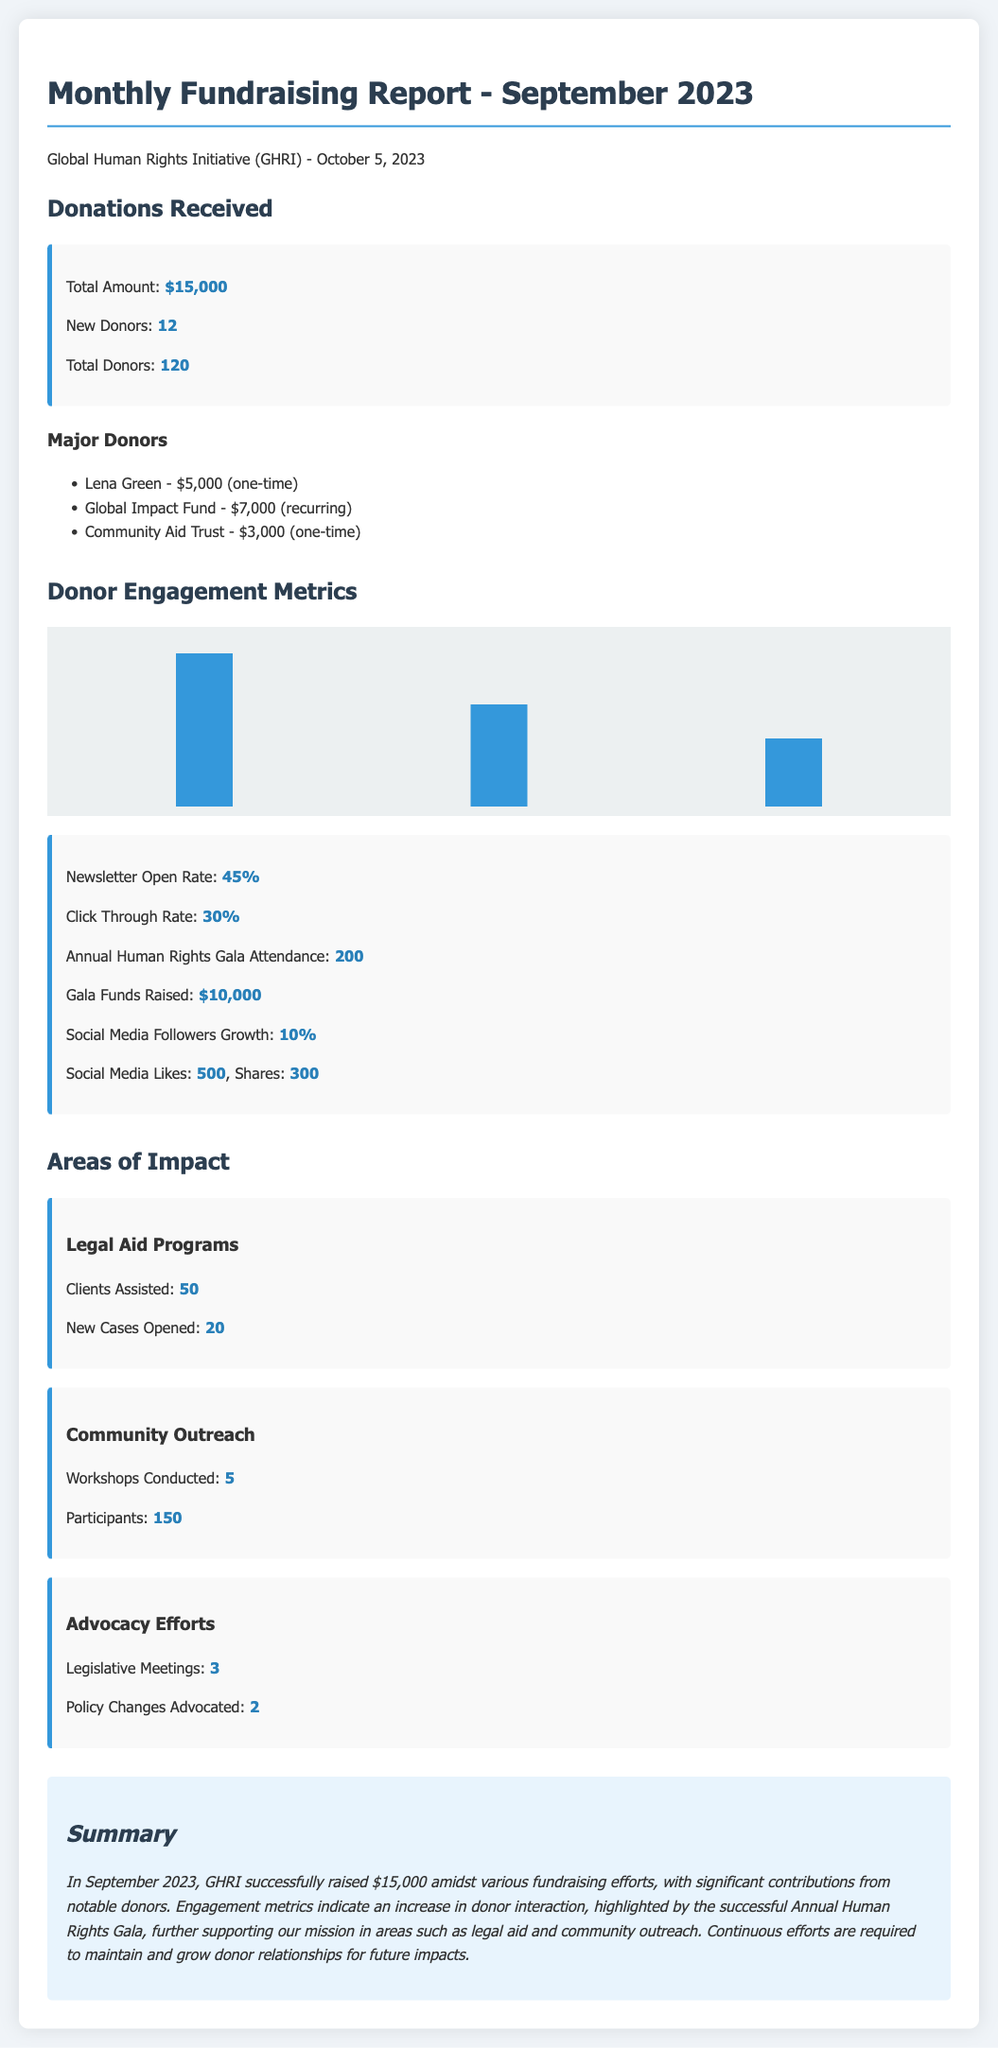What was the total amount raised in September 2023? The total amount raised is explicitly stated in the document under donations received.
Answer: $15,000 How many new donors were acquired in September 2023? The document provides the count of new donors in the donations section.
Answer: 12 What is the attendance for the Annual Human Rights Gala? The attendance figure is provided in the donor engagement metrics section.
Answer: 200 How many legal aid clients were assisted in September 2023? The number of clients assisted is mentioned under the legal aid programs area of impact.
Answer: 50 Who was the major donor that contributed $5,000? The name of the donor who contributed $5,000 is listed among the major donors.
Answer: Lena Green What was the social media followers growth percentage? The growth percentage of social media followers is noted in the donor engagement metrics.
Answer: 10% How many workshops were conducted under community outreach? The document indicates the number of workshops conducted in the community outreach section.
Answer: 5 How many legislative meetings were held in September 2023? The count of legislative meetings is stated in the advocacy efforts area of impact.
Answer: 3 What was the click-through rate for the newsletters? The document provides the click-through rate in the donor engagement metrics section.
Answer: 30% 